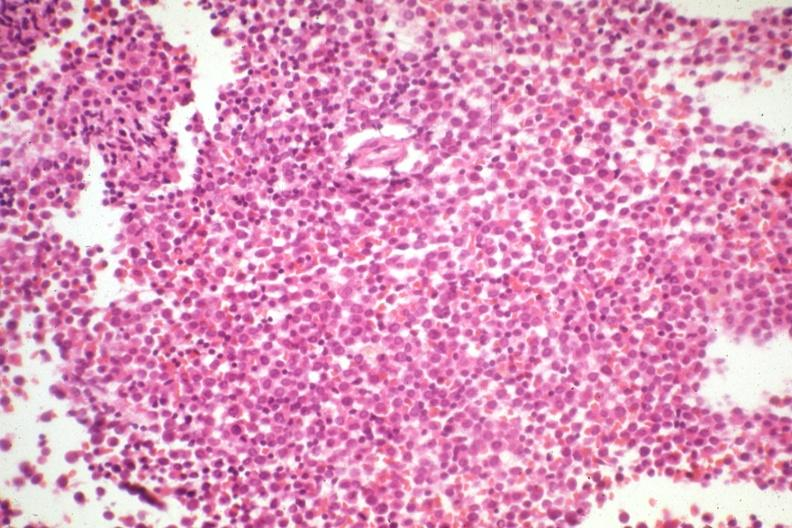s this section present?
Answer the question using a single word or phrase. No 